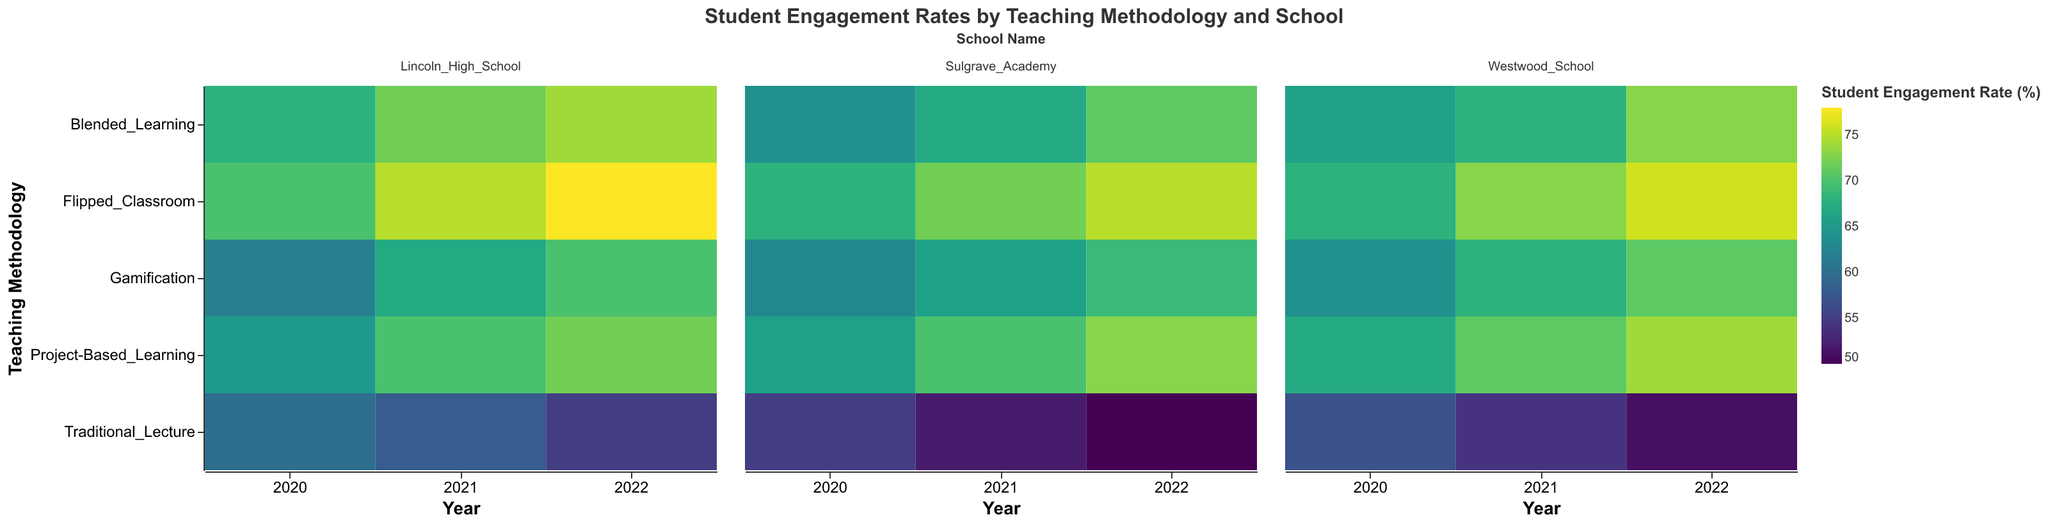What is the title of the heatmap? The heatmap title is positioned at the top center of the visual and reads "Student Engagement Rates by Teaching Methodology and School".
Answer: Student Engagement Rates by Teaching Methodology and School What year had the highest student engagement rate for the flipped classroom methodology at Lincoln High School? Examine the color gradient representing student engagement rates for the flipped classroom methodology at Lincoln High School. The darkest shade corresponds to the highest engagement rate.
Answer: 2022 How did student engagement rates change for traditional lectures at Sulgrave Academy from 2020 to 2022? Trace the progression of the color shades for traditional lectures at Sulgrave Academy across the years. The transition from lighter to darker shades indicates decreasing student engagement rates.
Answer: Decreased Which teaching methodology showed the most consistent increase in student engagement rates at Westwood School? Compare the shades of color for each teaching methodology over the years. The methodology with a progressively darker shade each year demonstrates a consistent increase.
Answer: Flipped Classroom What is the student engagement rate for blended learning at Lincoln High School in 2021? Hover over or look closely at the corresponding cell in the heatmap for this data point. View the tooltip or find the numerical value displayed.
Answer: 72 Among the teaching methodologies used at Sulgrave Academy, which one had the highest student engagement rate in 2021? Look for the darkest color shades in the year 2021 under Sulgrave Academy. Check which methodology corresponds to this shade.
Answer: Flipped Classroom Compare the student engagement rates for project-based learning between Lincoln High School and Westwood School in 2022. Which school had a higher rate? Identify the color gradient for project-based learning for both schools in 2022. Compare the relative darkness of the shades.
Answer: Westwood School What is the average student engagement rate in 2020 for gamification across all schools? Locate the engagement rates for gamification in 2020 across Lincoln High School, Sulgrave Academy, and Westwood School. Sum these values and divide by the number of schools.
Answer: 63 How does the trend in student engagement rates for traditional lectures at Westwood School differ from Lincoln High School over the years? Compare the changes in color gradients for traditional lectures across the years for both schools. Note the direction and rate of changes.
Answer: Lincoln High School shows a more pronounced decrease in engagement rates compared to Westwood School Which school showed the highest overall student engagement rate for any teaching methodology in 2022? Look for the darkest color cell across all methodologies and schools in the year 2022. Identify the school linked to this cell.
Answer: Lincoln High School 